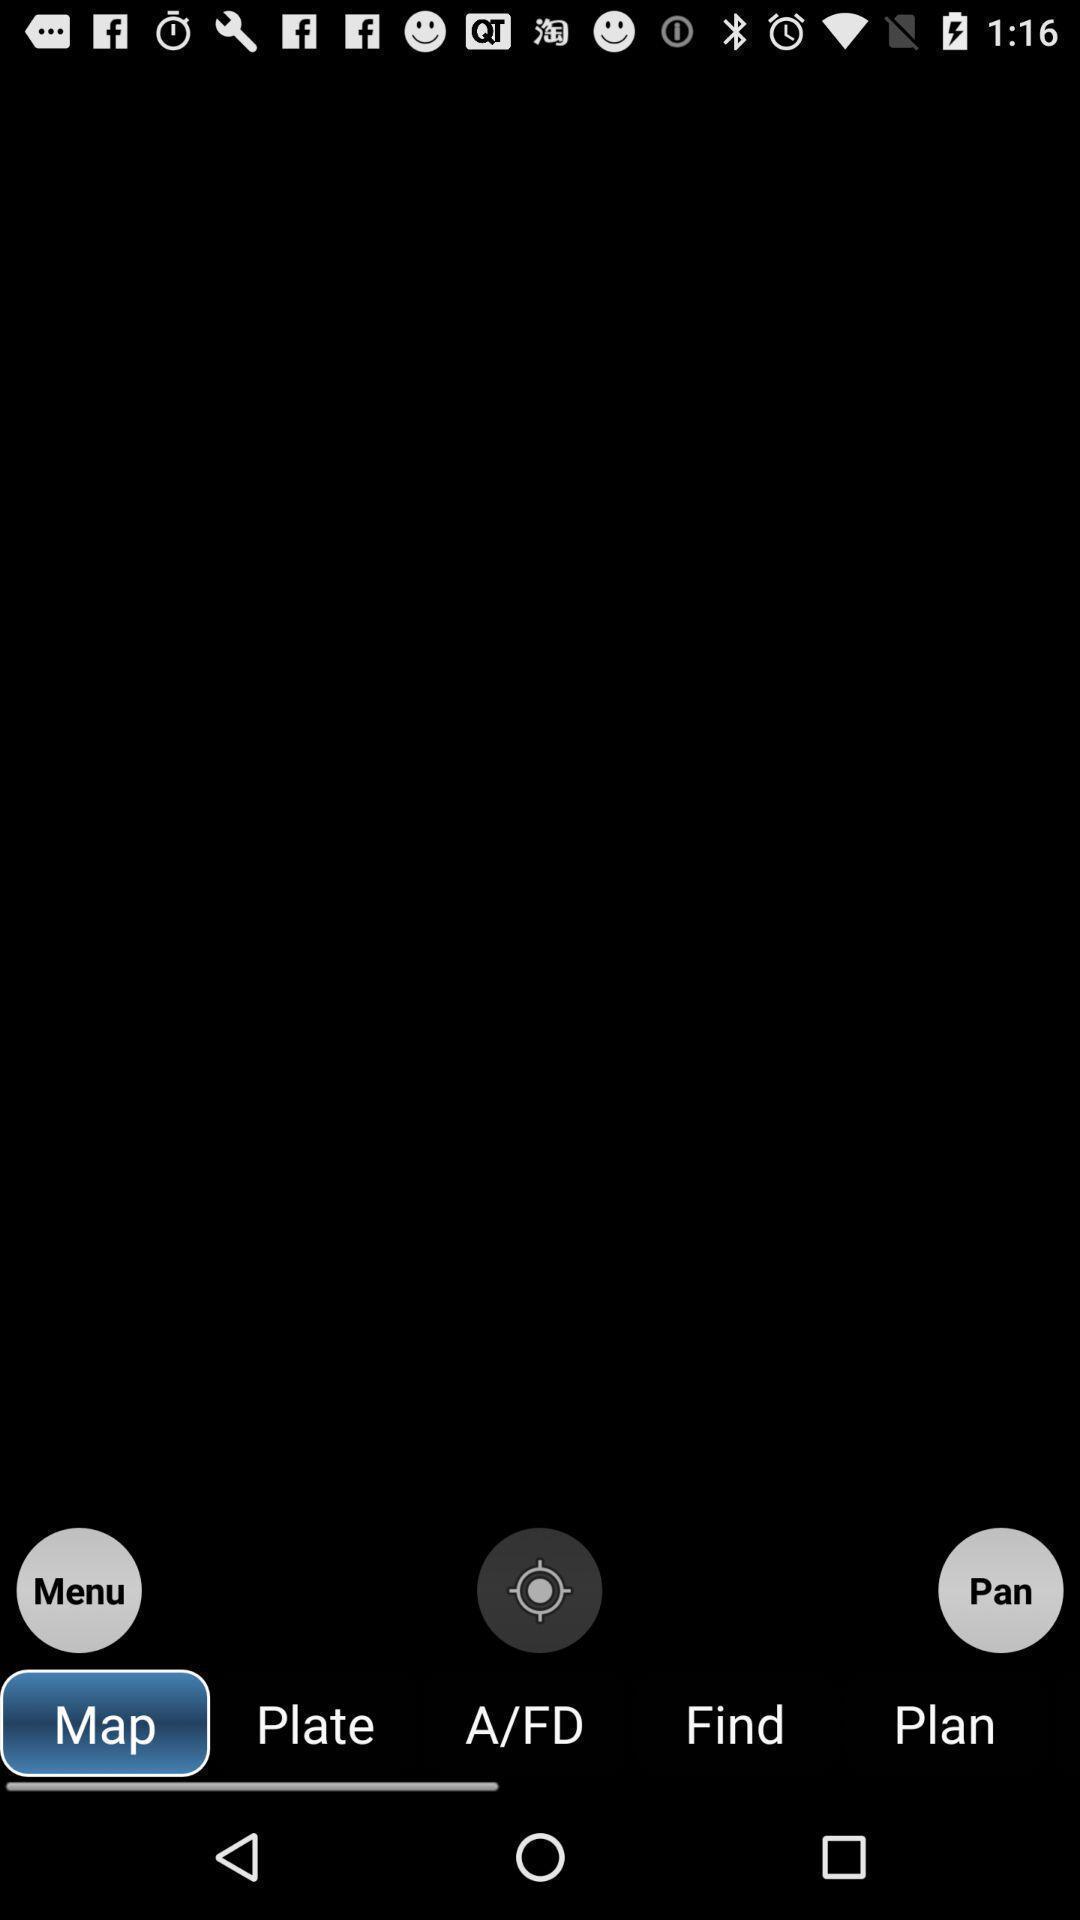Summarize the main components in this picture. Screen showing various options like location. 